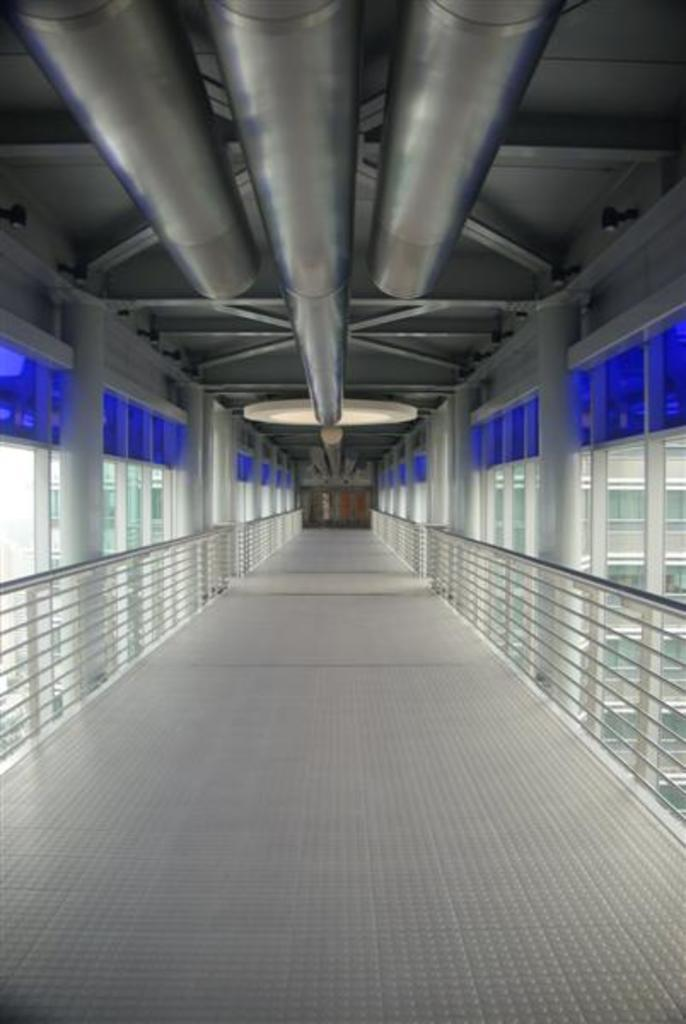What structure is the main subject of the image? There is a bridge in the image. What feature can be seen on the bridge? The bridge has railings. What can be seen in the background of the image? There is a building in the background of the image. What objects are visible at the top of the image? There are pipes visible at the top of the image. How does the wealth of the people in the image affect the condition of the bridge? There is no information about the wealth of the people or the condition of the bridge in the image. Can you tell me how much debt the bridge has in the image? There is no information about the bridge's debt in the image. 